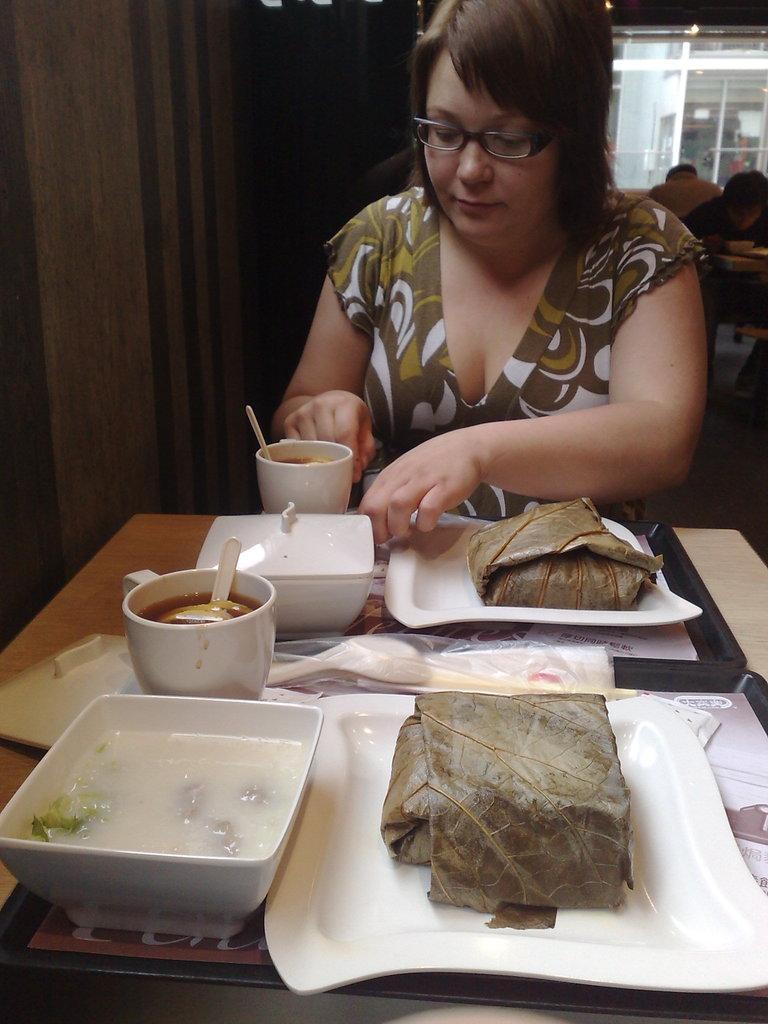Could you give a brief overview of what you see in this image? In this image we can see a woman wearing the spectacles, in front of her we can see a table, on the table, there are some plates, bowls with some food and cups, in the background we can see two persons sitting. 